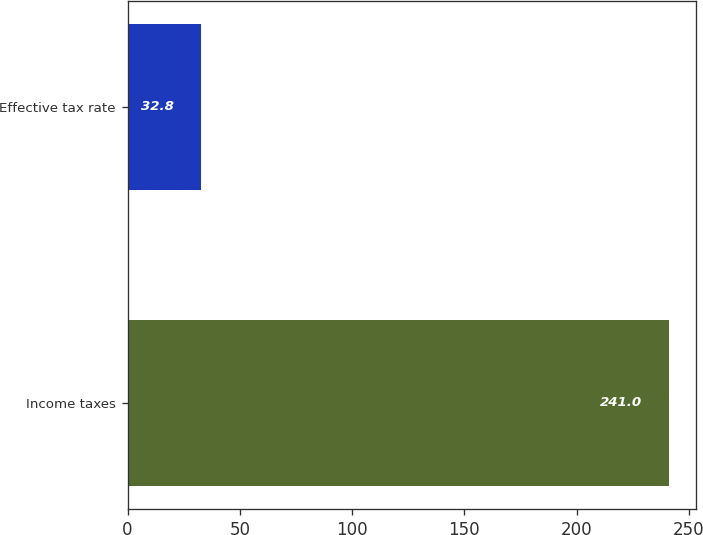<chart> <loc_0><loc_0><loc_500><loc_500><bar_chart><fcel>Income taxes<fcel>Effective tax rate<nl><fcel>241<fcel>32.8<nl></chart> 